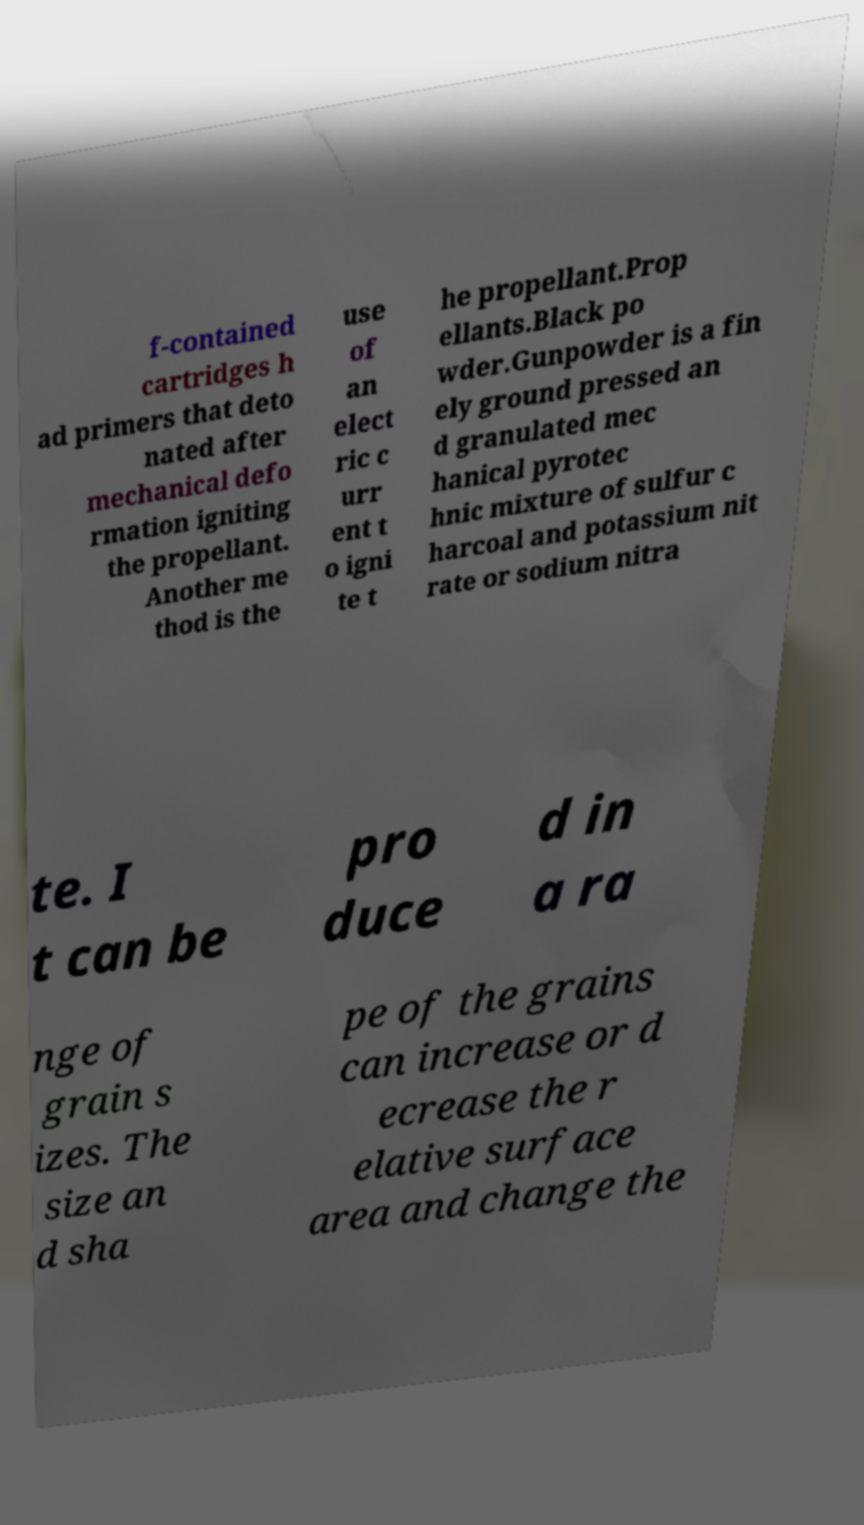Can you accurately transcribe the text from the provided image for me? f-contained cartridges h ad primers that deto nated after mechanical defo rmation igniting the propellant. Another me thod is the use of an elect ric c urr ent t o igni te t he propellant.Prop ellants.Black po wder.Gunpowder is a fin ely ground pressed an d granulated mec hanical pyrotec hnic mixture of sulfur c harcoal and potassium nit rate or sodium nitra te. I t can be pro duce d in a ra nge of grain s izes. The size an d sha pe of the grains can increase or d ecrease the r elative surface area and change the 